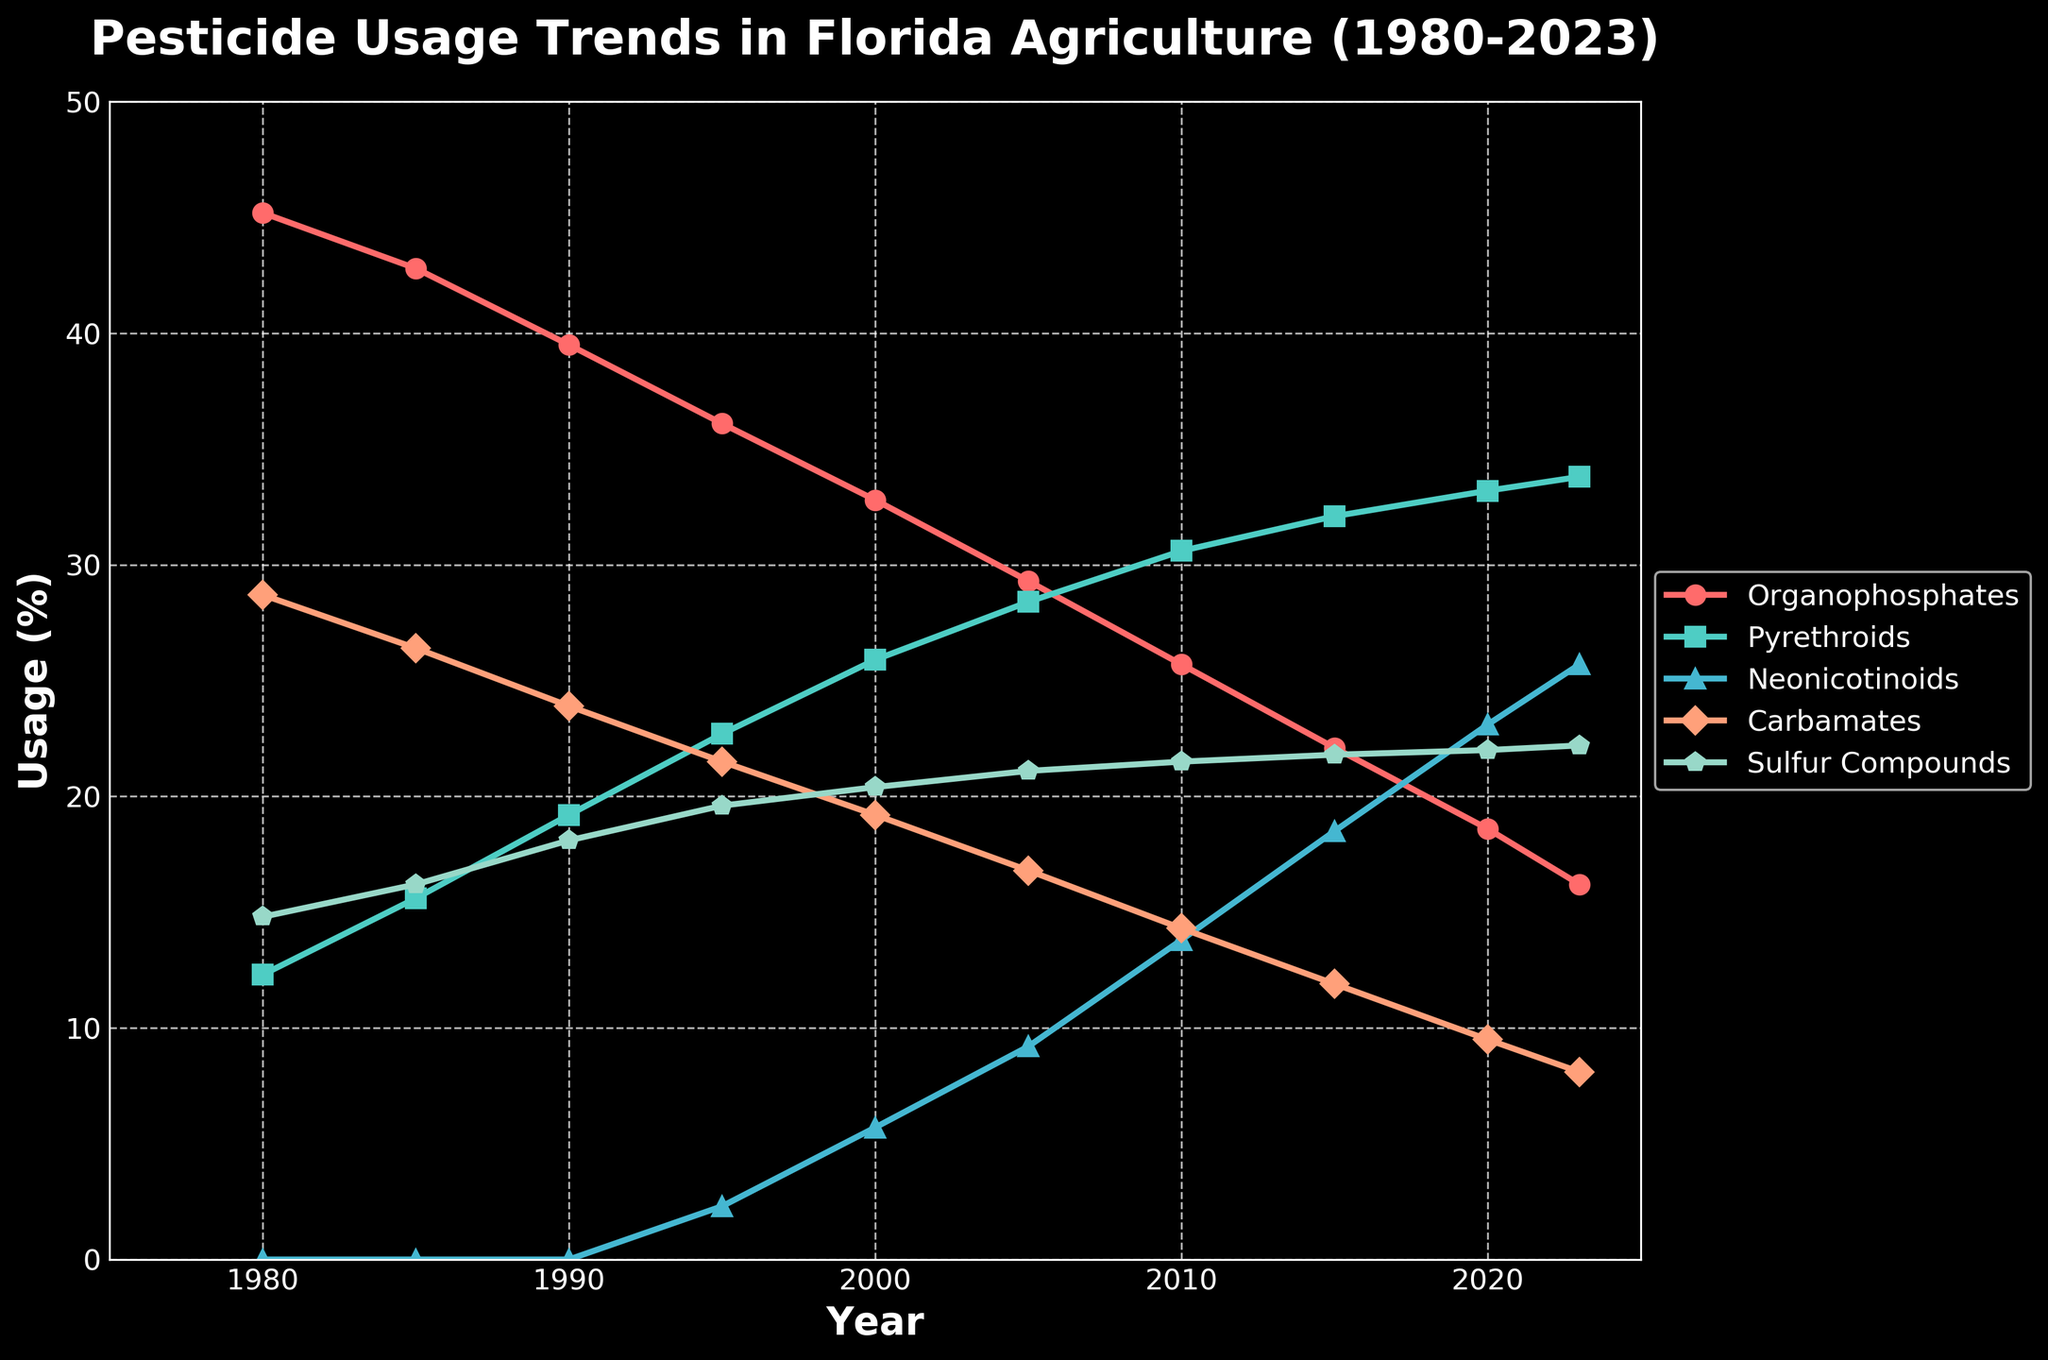What pesticide category has the highest usage in 2023? Look at the end of the line plot for the year 2023 and identify the highest point among all categories. Pyrethroids have the highest usage in 2023.
Answer: Pyrethroids Which pesticide category shows a decreasing trend from 1980 to 2023? Look at all the lines from 1980 to 2023, identify the lines that are continuously going down. Organophosphates show a decreasing trend over time.
Answer: Organophosphates How many years does it take for Neonicotinoids to surpass 20% in usage? Identify when Neonicotinoids first appear in the chart, look for the point when its usage exceeds 20%, and calculate the difference in years. Neonicotinoids first appear in 1995. They exceed 20% usage in 2015, taking 20 years.
Answer: 20 years Which category had the steepest increase in usage from 1980 to 2023? Look at the slopes of all the lines, identify which line has the steepest upward trend. The line for Neonicotinoids shows the steepest increase in usage.
Answer: Neonicotinoids Which two categories have the closest usage percentages in 2010? Look for the points where the lines intersect or are closest in 2010. Carbamates and Sulfur Compounds have usage percentages very close to each other in 2010.
Answer: Carbamates and Sulfur Compounds In what year did Pyrethroids surpass Organophosphates in usage? Find the year where the Pyrethroids line crosses above the Organophosphates line. Pyrethroids surpass Organophosphates around the year 1990.
Answer: 1990 What's the difference in usage between Pyrethroids and Neonicotinoids in 2023? Identify the usage percentages for Pyrethroids and Neonicotinoids in 2023 and subtract the Neonicotinoids value from the Pyrethroids value. Pyrethroids have 33.8%, Neonicotinoids have 25.7%. The difference is 33.8 - 25.7.
Answer: 8.1% What is the average usage of Sulfur Compounds over the whole period provided? Sum up all the percentages of Sulfur Compounds from 1980 to 2023, then divide by the number of years (10). (14.8 + 16.2 + 18.1 + 19.6 + 20.4 + 21.1 + 21.5 + 21.8 + 22.0 + 22.2) / 10 = 19.77.
Answer: 19.77% Visualize Organophosphates and Pyrethroids in 1980, what is the visual difference between the two? Look at the beginning points of the lines for Organophosphates and Pyrethroids in 1980 and note how they differ in height. Organophosphates are significantly higher than Pyrethroids in 1980.
Answer: Organophosphates higher 